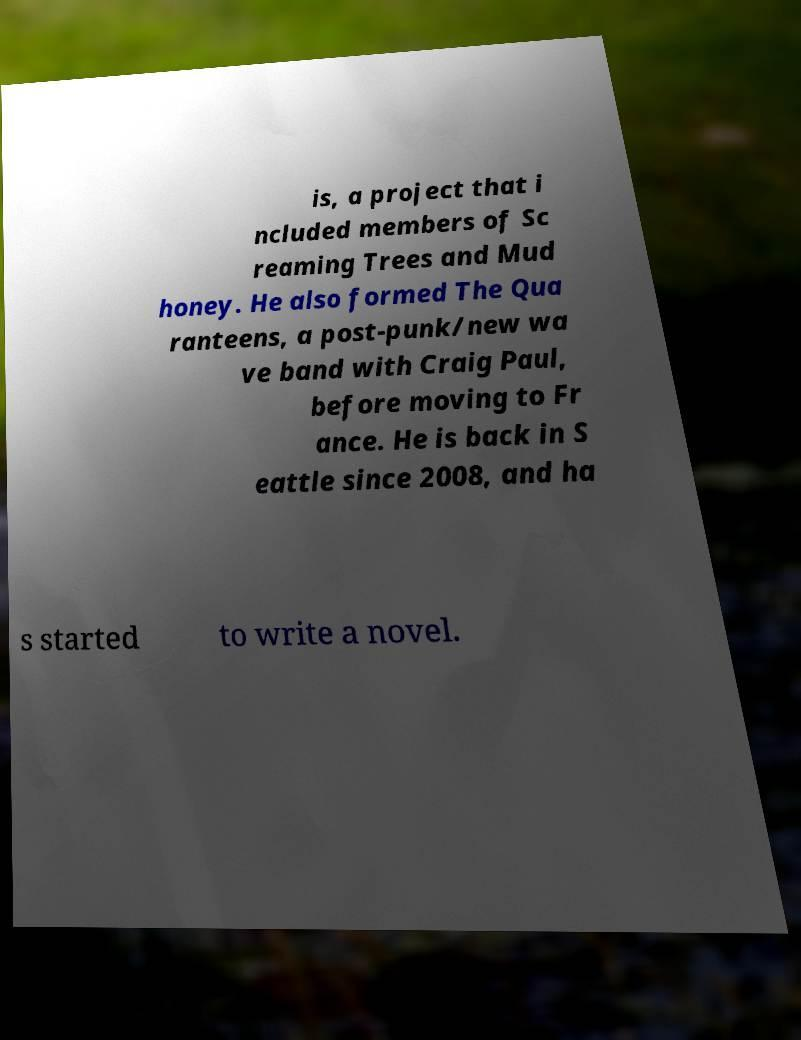Can you read and provide the text displayed in the image?This photo seems to have some interesting text. Can you extract and type it out for me? is, a project that i ncluded members of Sc reaming Trees and Mud honey. He also formed The Qua ranteens, a post-punk/new wa ve band with Craig Paul, before moving to Fr ance. He is back in S eattle since 2008, and ha s started to write a novel. 